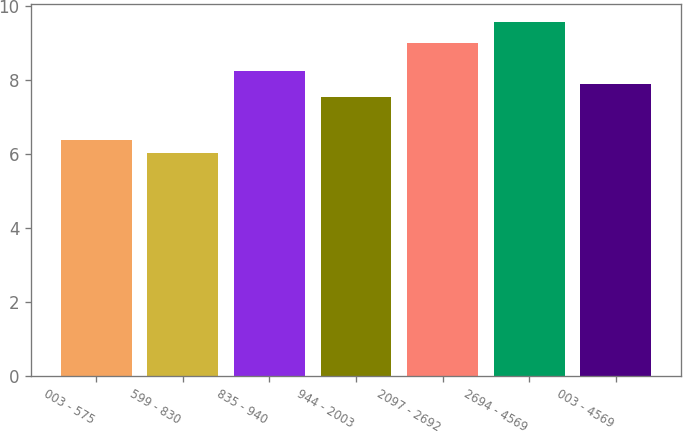Convert chart. <chart><loc_0><loc_0><loc_500><loc_500><bar_chart><fcel>003 - 575<fcel>599 - 830<fcel>835 - 940<fcel>944 - 2003<fcel>2097 - 2692<fcel>2694 - 4569<fcel>003 - 4569<nl><fcel>6.39<fcel>6.04<fcel>8.25<fcel>7.55<fcel>9.01<fcel>9.58<fcel>7.9<nl></chart> 